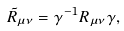Convert formula to latex. <formula><loc_0><loc_0><loc_500><loc_500>\tilde { R } _ { \mu \nu } = \gamma ^ { - 1 } R _ { \mu \nu } \gamma ,</formula> 